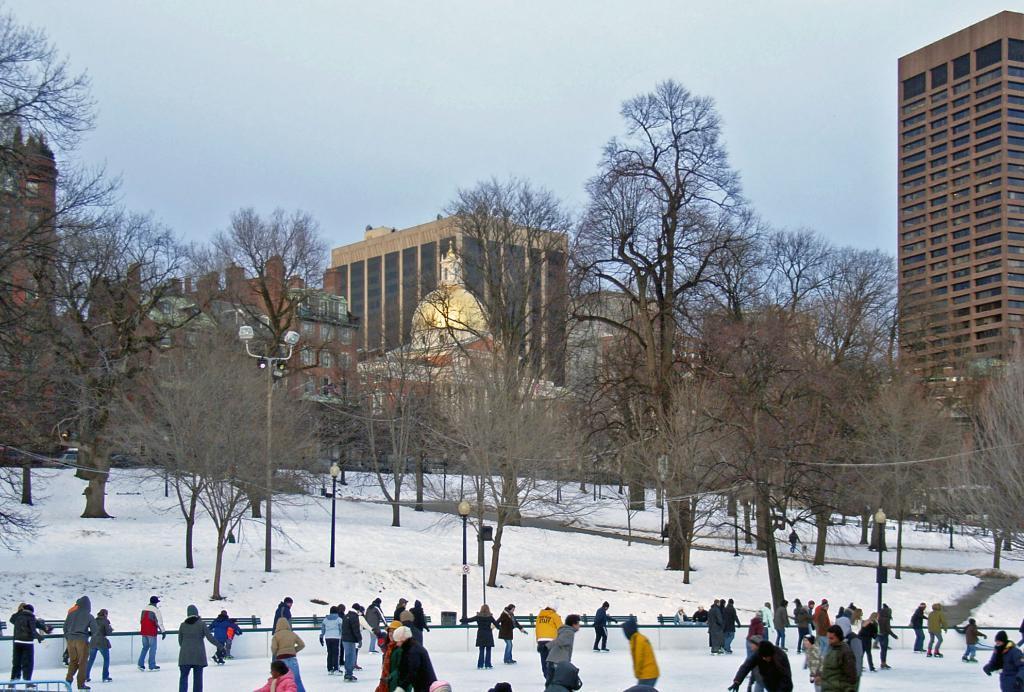In one or two sentences, can you explain what this image depicts? In this image at front people are skating on the surface of the snow. At the back side there are lights. At the background there are trees, buildings, statue and sky. 